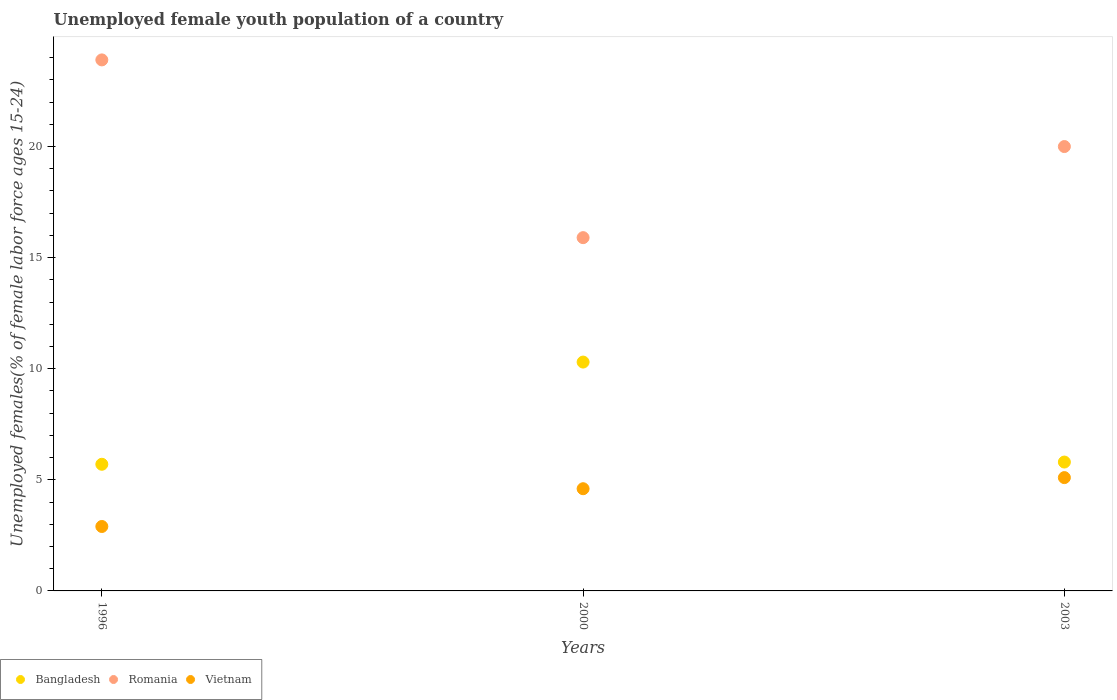How many different coloured dotlines are there?
Your answer should be compact. 3. Is the number of dotlines equal to the number of legend labels?
Make the answer very short. Yes. What is the percentage of unemployed female youth population in Bangladesh in 2000?
Offer a terse response. 10.3. Across all years, what is the maximum percentage of unemployed female youth population in Bangladesh?
Keep it short and to the point. 10.3. Across all years, what is the minimum percentage of unemployed female youth population in Romania?
Provide a short and direct response. 15.9. In which year was the percentage of unemployed female youth population in Romania minimum?
Give a very brief answer. 2000. What is the total percentage of unemployed female youth population in Romania in the graph?
Ensure brevity in your answer.  59.8. What is the difference between the percentage of unemployed female youth population in Romania in 1996 and that in 2000?
Ensure brevity in your answer.  8. What is the difference between the percentage of unemployed female youth population in Bangladesh in 2003 and the percentage of unemployed female youth population in Romania in 1996?
Your response must be concise. -18.1. What is the average percentage of unemployed female youth population in Bangladesh per year?
Your answer should be very brief. 7.27. In the year 1996, what is the difference between the percentage of unemployed female youth population in Vietnam and percentage of unemployed female youth population in Romania?
Provide a succinct answer. -21. What is the ratio of the percentage of unemployed female youth population in Romania in 1996 to that in 2000?
Your answer should be compact. 1.5. What is the difference between the highest and the second highest percentage of unemployed female youth population in Romania?
Keep it short and to the point. 3.9. What is the difference between the highest and the lowest percentage of unemployed female youth population in Vietnam?
Give a very brief answer. 2.2. Is the sum of the percentage of unemployed female youth population in Vietnam in 1996 and 2000 greater than the maximum percentage of unemployed female youth population in Bangladesh across all years?
Your response must be concise. No. Does the percentage of unemployed female youth population in Romania monotonically increase over the years?
Offer a very short reply. No. Is the percentage of unemployed female youth population in Bangladesh strictly greater than the percentage of unemployed female youth population in Romania over the years?
Give a very brief answer. No. Is the percentage of unemployed female youth population in Bangladesh strictly less than the percentage of unemployed female youth population in Romania over the years?
Your answer should be compact. Yes. How many dotlines are there?
Offer a terse response. 3. Are the values on the major ticks of Y-axis written in scientific E-notation?
Keep it short and to the point. No. Where does the legend appear in the graph?
Keep it short and to the point. Bottom left. How many legend labels are there?
Make the answer very short. 3. What is the title of the graph?
Provide a succinct answer. Unemployed female youth population of a country. What is the label or title of the X-axis?
Make the answer very short. Years. What is the label or title of the Y-axis?
Your response must be concise. Unemployed females(% of female labor force ages 15-24). What is the Unemployed females(% of female labor force ages 15-24) of Bangladesh in 1996?
Your response must be concise. 5.7. What is the Unemployed females(% of female labor force ages 15-24) in Romania in 1996?
Give a very brief answer. 23.9. What is the Unemployed females(% of female labor force ages 15-24) in Vietnam in 1996?
Give a very brief answer. 2.9. What is the Unemployed females(% of female labor force ages 15-24) of Bangladesh in 2000?
Keep it short and to the point. 10.3. What is the Unemployed females(% of female labor force ages 15-24) in Romania in 2000?
Give a very brief answer. 15.9. What is the Unemployed females(% of female labor force ages 15-24) of Vietnam in 2000?
Your answer should be compact. 4.6. What is the Unemployed females(% of female labor force ages 15-24) of Bangladesh in 2003?
Your answer should be very brief. 5.8. What is the Unemployed females(% of female labor force ages 15-24) in Romania in 2003?
Give a very brief answer. 20. What is the Unemployed females(% of female labor force ages 15-24) in Vietnam in 2003?
Ensure brevity in your answer.  5.1. Across all years, what is the maximum Unemployed females(% of female labor force ages 15-24) in Bangladesh?
Make the answer very short. 10.3. Across all years, what is the maximum Unemployed females(% of female labor force ages 15-24) in Romania?
Keep it short and to the point. 23.9. Across all years, what is the maximum Unemployed females(% of female labor force ages 15-24) in Vietnam?
Ensure brevity in your answer.  5.1. Across all years, what is the minimum Unemployed females(% of female labor force ages 15-24) in Bangladesh?
Offer a very short reply. 5.7. Across all years, what is the minimum Unemployed females(% of female labor force ages 15-24) of Romania?
Your answer should be compact. 15.9. Across all years, what is the minimum Unemployed females(% of female labor force ages 15-24) of Vietnam?
Your response must be concise. 2.9. What is the total Unemployed females(% of female labor force ages 15-24) of Bangladesh in the graph?
Provide a succinct answer. 21.8. What is the total Unemployed females(% of female labor force ages 15-24) of Romania in the graph?
Your answer should be compact. 59.8. What is the total Unemployed females(% of female labor force ages 15-24) of Vietnam in the graph?
Keep it short and to the point. 12.6. What is the difference between the Unemployed females(% of female labor force ages 15-24) of Romania in 1996 and that in 2000?
Your response must be concise. 8. What is the difference between the Unemployed females(% of female labor force ages 15-24) of Romania in 2000 and that in 2003?
Give a very brief answer. -4.1. What is the difference between the Unemployed females(% of female labor force ages 15-24) of Vietnam in 2000 and that in 2003?
Your response must be concise. -0.5. What is the difference between the Unemployed females(% of female labor force ages 15-24) in Bangladesh in 1996 and the Unemployed females(% of female labor force ages 15-24) in Romania in 2000?
Provide a short and direct response. -10.2. What is the difference between the Unemployed females(% of female labor force ages 15-24) of Romania in 1996 and the Unemployed females(% of female labor force ages 15-24) of Vietnam in 2000?
Offer a terse response. 19.3. What is the difference between the Unemployed females(% of female labor force ages 15-24) of Bangladesh in 1996 and the Unemployed females(% of female labor force ages 15-24) of Romania in 2003?
Offer a terse response. -14.3. What is the difference between the Unemployed females(% of female labor force ages 15-24) in Bangladesh in 1996 and the Unemployed females(% of female labor force ages 15-24) in Vietnam in 2003?
Provide a succinct answer. 0.6. What is the average Unemployed females(% of female labor force ages 15-24) of Bangladesh per year?
Your answer should be compact. 7.27. What is the average Unemployed females(% of female labor force ages 15-24) in Romania per year?
Make the answer very short. 19.93. In the year 1996, what is the difference between the Unemployed females(% of female labor force ages 15-24) of Bangladesh and Unemployed females(% of female labor force ages 15-24) of Romania?
Your response must be concise. -18.2. In the year 1996, what is the difference between the Unemployed females(% of female labor force ages 15-24) of Bangladesh and Unemployed females(% of female labor force ages 15-24) of Vietnam?
Keep it short and to the point. 2.8. In the year 1996, what is the difference between the Unemployed females(% of female labor force ages 15-24) of Romania and Unemployed females(% of female labor force ages 15-24) of Vietnam?
Provide a succinct answer. 21. In the year 2000, what is the difference between the Unemployed females(% of female labor force ages 15-24) in Bangladesh and Unemployed females(% of female labor force ages 15-24) in Romania?
Provide a short and direct response. -5.6. In the year 2000, what is the difference between the Unemployed females(% of female labor force ages 15-24) of Bangladesh and Unemployed females(% of female labor force ages 15-24) of Vietnam?
Provide a succinct answer. 5.7. In the year 2000, what is the difference between the Unemployed females(% of female labor force ages 15-24) of Romania and Unemployed females(% of female labor force ages 15-24) of Vietnam?
Give a very brief answer. 11.3. In the year 2003, what is the difference between the Unemployed females(% of female labor force ages 15-24) of Bangladesh and Unemployed females(% of female labor force ages 15-24) of Vietnam?
Offer a terse response. 0.7. In the year 2003, what is the difference between the Unemployed females(% of female labor force ages 15-24) of Romania and Unemployed females(% of female labor force ages 15-24) of Vietnam?
Provide a succinct answer. 14.9. What is the ratio of the Unemployed females(% of female labor force ages 15-24) of Bangladesh in 1996 to that in 2000?
Make the answer very short. 0.55. What is the ratio of the Unemployed females(% of female labor force ages 15-24) in Romania in 1996 to that in 2000?
Your answer should be very brief. 1.5. What is the ratio of the Unemployed females(% of female labor force ages 15-24) of Vietnam in 1996 to that in 2000?
Keep it short and to the point. 0.63. What is the ratio of the Unemployed females(% of female labor force ages 15-24) of Bangladesh in 1996 to that in 2003?
Your response must be concise. 0.98. What is the ratio of the Unemployed females(% of female labor force ages 15-24) in Romania in 1996 to that in 2003?
Offer a very short reply. 1.2. What is the ratio of the Unemployed females(% of female labor force ages 15-24) in Vietnam in 1996 to that in 2003?
Your response must be concise. 0.57. What is the ratio of the Unemployed females(% of female labor force ages 15-24) in Bangladesh in 2000 to that in 2003?
Your answer should be very brief. 1.78. What is the ratio of the Unemployed females(% of female labor force ages 15-24) of Romania in 2000 to that in 2003?
Offer a very short reply. 0.8. What is the ratio of the Unemployed females(% of female labor force ages 15-24) in Vietnam in 2000 to that in 2003?
Make the answer very short. 0.9. What is the difference between the highest and the second highest Unemployed females(% of female labor force ages 15-24) of Vietnam?
Your response must be concise. 0.5. What is the difference between the highest and the lowest Unemployed females(% of female labor force ages 15-24) of Romania?
Make the answer very short. 8. What is the difference between the highest and the lowest Unemployed females(% of female labor force ages 15-24) of Vietnam?
Ensure brevity in your answer.  2.2. 